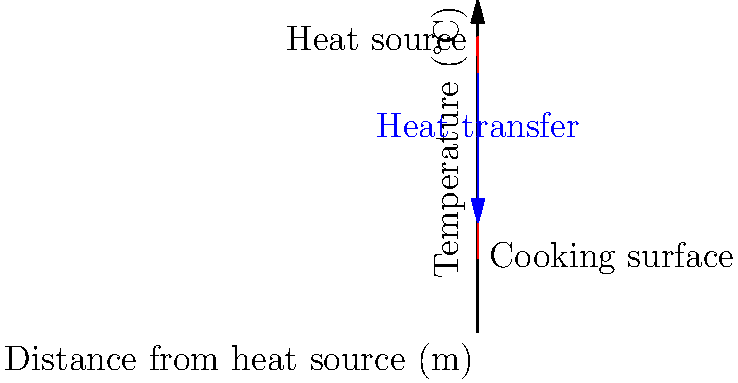In an emergency cooking stove, heat is transferred from the heat source to the cooking surface. Based on the temperature gradient shown in the illustration, calculate the rate of heat transfer per unit area if the thermal conductivity of the stove material is 15 W/(m·K) and the distance between the heat source and cooking surface is 0.5 m. To solve this problem, we'll use Fourier's law of heat conduction:

1. Fourier's law: $q = -k \frac{dT}{dx}$

   Where:
   $q$ = heat flux (W/m²)
   $k$ = thermal conductivity (W/(m·K))
   $\frac{dT}{dx}$ = temperature gradient (K/m)

2. From the graph, we can determine:
   - Temperature at heat source (x = 0 m): $T_1 = 800°C$
   - Temperature at cooking surface (x = 1 m): $T_2 = 200°C$

3. Calculate the temperature gradient:
   $\frac{dT}{dx} = \frac{T_2 - T_1}{x_2 - x_1} = \frac{200°C - 800°C}{1m - 0m} = -600°C/m$

4. Convert the temperature gradient to K/m:
   $-600°C/m = -600 K/m$ (temperature difference is the same in °C and K)

5. Apply Fourier's law:
   $q = -k \frac{dT}{dx}$
   $q = -(15 \text{ W/(m·K)}) \times (-600 \text{ K/m})$
   $q = 9000 \text{ W/m²}$

Therefore, the rate of heat transfer per unit area is 9000 W/m².
Answer: 9000 W/m² 